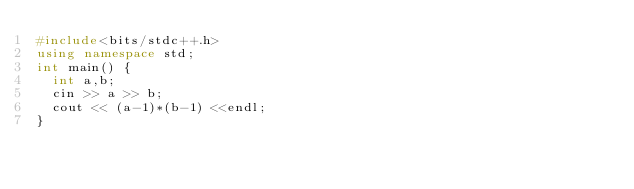<code> <loc_0><loc_0><loc_500><loc_500><_C++_>#include<bits/stdc++.h>
using namespace std;
int main() {
  int a,b;
  cin >> a >> b;
  cout << (a-1)*(b-1) <<endl;
}</code> 